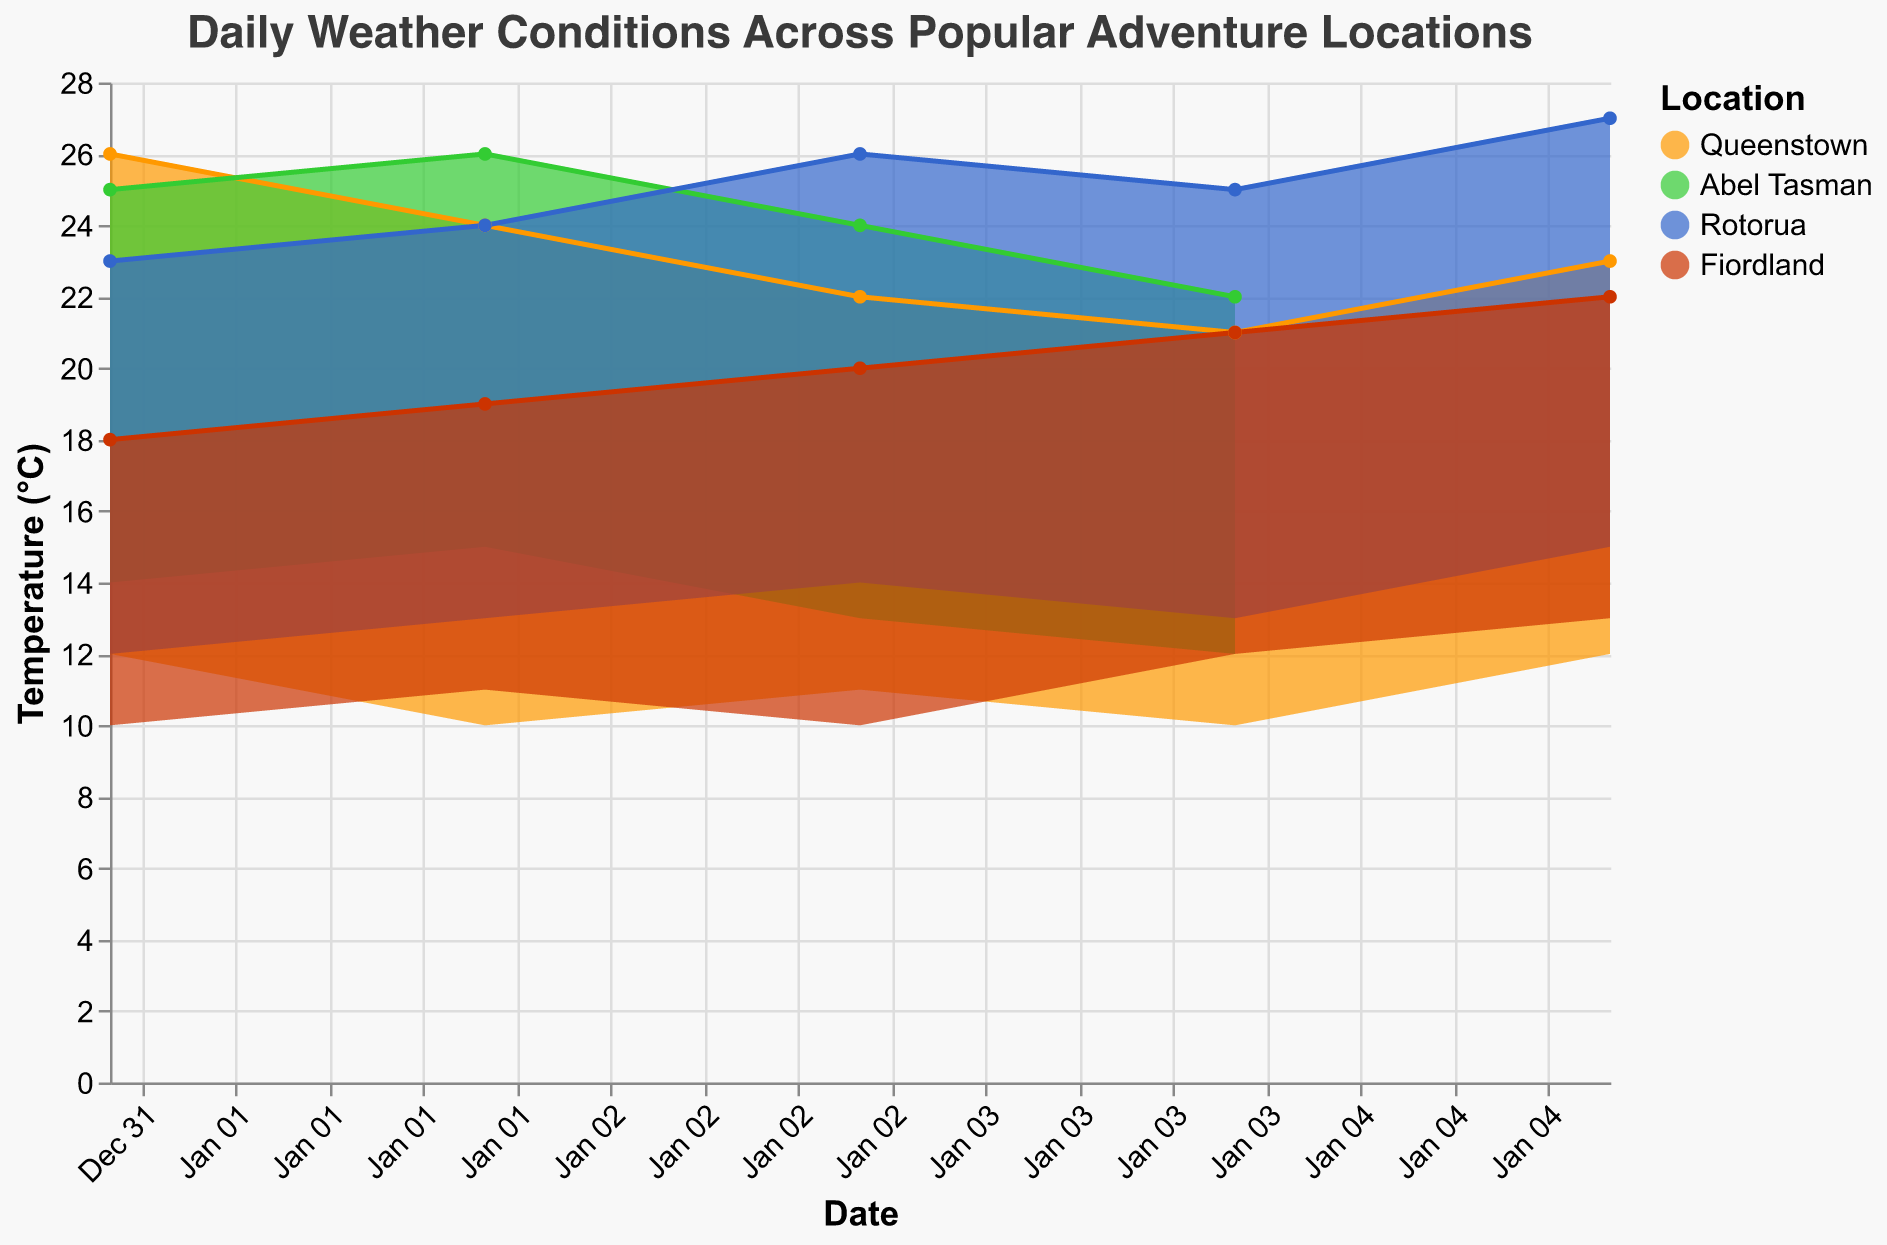What is the title of the chart? The title of the chart is prominently displayed at the top of the figure and can be seen without any analysis.
Answer: Daily Weather Conditions Across Popular Adventure Locations How many locations are compared in the chart? The chart uses different colors to represent different locations, and the legend shows the names of these locations.
Answer: Four Which location recorded the highest maximum temperature on January 5th? The highest maximum temperature is represented by the highest point on the vertical axis labeled with dates. On January 5th, Rotorua had the highest maximum temperature.
Answer: Rotorua Which location had the most days with rain from January 1st to January 5th? By analyzing the weather conditions provided in the tooltip for different dates, Fiordland had rain on January 1st and 2nd, the highest number of rainy days compared to the other locations.
Answer: Fiordland Which day had the highest amount of precipitation in Queenstown? The chart's tooltip reveals the amount of precipitation for specific dates. January 4th in Queenstown had the highest precipitation with 8mm.
Answer: January 4th Compare the range of temperatures (max_temp - min_temp) on January 2nd between Rotorua and Queenstown. Which location had a larger range? Calculate the range for each location: Queenstown (24-10=14) and Rotorua (24-13=11). Queenstown had a larger range.
Answer: Queenstown What was the average maximum temperature in Abel Tasman over the period January 1st to 4th? Sum the maximum temperatures (25 + 26 + 24 + 22 = 97) and divide by 4 (number of days). The average is 97/4 = 24.25.
Answer: 24.25°C Which location had the lowest minimum temperature on January 1st? The lowest minimum temperature is the lowest point on the vertical axis, and the tooltip confirms Fiordland had the lowest minimum temperature of 10°C.
Answer: Fiordland True or False: Rotorua experienced sunny weather on more days than Queenstown from January 1st to 5th. Count the number of sunny days in the tooltip for each location. Rotorua had 3 sunny days, and Queenstown had 1. Therefore, the statement is True.
Answer: True Describe the weather pattern in Queenstown from January 1st to January 5th. By analyzing the tooltip and looking at each day's weather condition in Queenstown: Rain on January 1st, Sunny on January 2nd, Cloudy on January 3rd, Rain on January 4th, and Windy on January 5th.
Answer: Rain, Sunny, Cloudy, Rain, Windy 